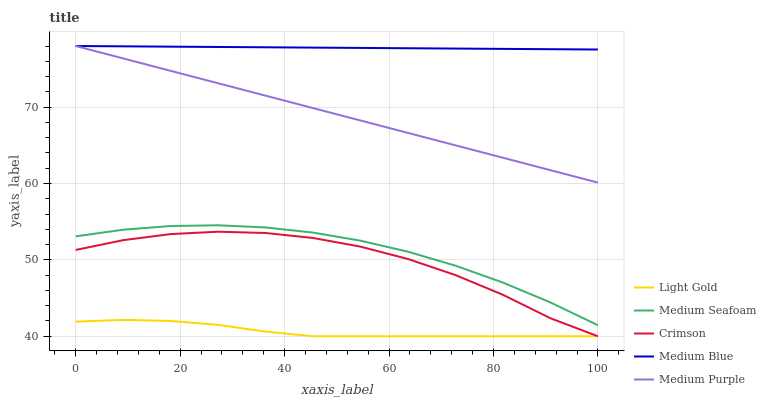Does Medium Purple have the minimum area under the curve?
Answer yes or no. No. Does Medium Purple have the maximum area under the curve?
Answer yes or no. No. Is Medium Blue the smoothest?
Answer yes or no. No. Is Medium Blue the roughest?
Answer yes or no. No. Does Medium Purple have the lowest value?
Answer yes or no. No. Does Light Gold have the highest value?
Answer yes or no. No. Is Light Gold less than Medium Purple?
Answer yes or no. Yes. Is Medium Blue greater than Light Gold?
Answer yes or no. Yes. Does Light Gold intersect Medium Purple?
Answer yes or no. No. 